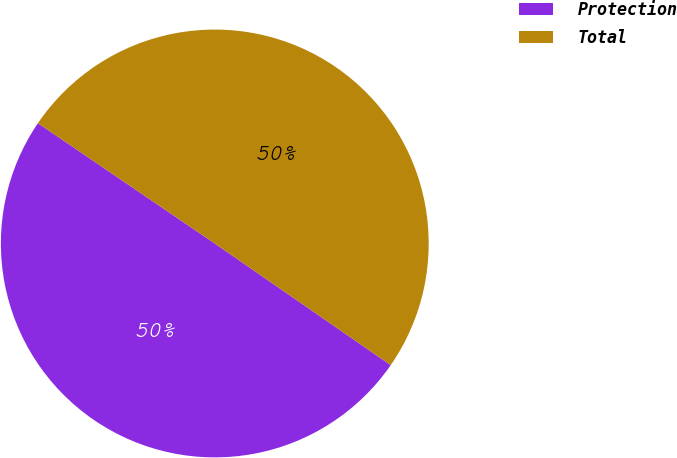Convert chart to OTSL. <chart><loc_0><loc_0><loc_500><loc_500><pie_chart><fcel>Protection<fcel>Total<nl><fcel>49.88%<fcel>50.12%<nl></chart> 